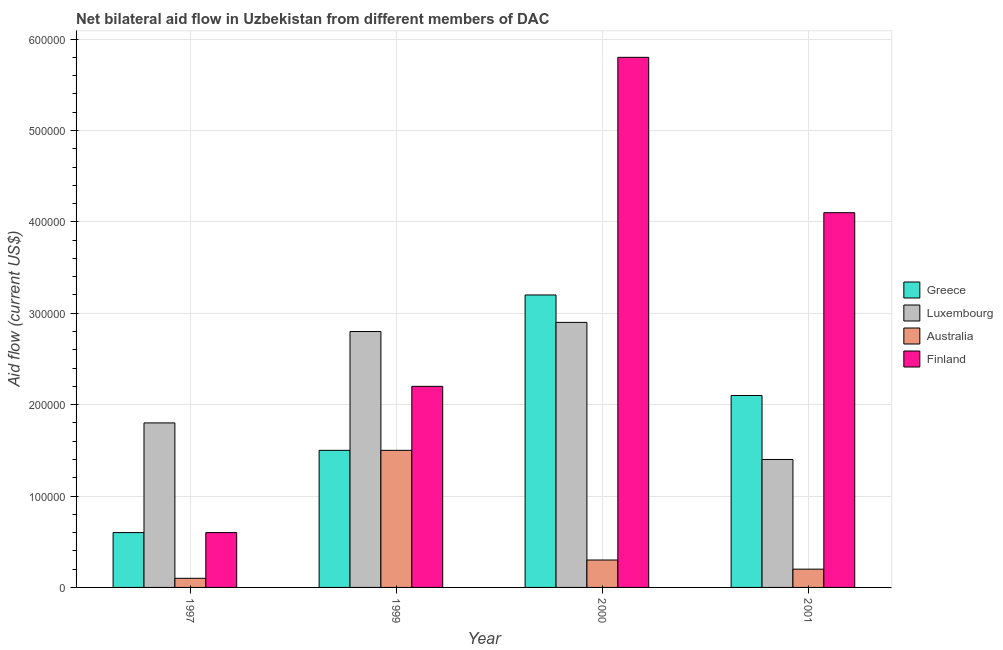How many different coloured bars are there?
Keep it short and to the point. 4. Are the number of bars per tick equal to the number of legend labels?
Offer a very short reply. Yes. How many bars are there on the 3rd tick from the right?
Make the answer very short. 4. In how many cases, is the number of bars for a given year not equal to the number of legend labels?
Your answer should be compact. 0. What is the amount of aid given by finland in 2001?
Give a very brief answer. 4.10e+05. Across all years, what is the maximum amount of aid given by australia?
Keep it short and to the point. 1.50e+05. Across all years, what is the minimum amount of aid given by australia?
Offer a terse response. 10000. In which year was the amount of aid given by finland maximum?
Keep it short and to the point. 2000. In which year was the amount of aid given by luxembourg minimum?
Ensure brevity in your answer.  2001. What is the total amount of aid given by finland in the graph?
Your answer should be very brief. 1.27e+06. What is the difference between the amount of aid given by luxembourg in 1999 and that in 2001?
Offer a very short reply. 1.40e+05. What is the difference between the amount of aid given by finland in 2001 and the amount of aid given by australia in 2000?
Your answer should be compact. -1.70e+05. What is the average amount of aid given by luxembourg per year?
Offer a very short reply. 2.22e+05. In the year 2000, what is the difference between the amount of aid given by australia and amount of aid given by greece?
Make the answer very short. 0. In how many years, is the amount of aid given by greece greater than 240000 US$?
Your answer should be very brief. 1. What is the ratio of the amount of aid given by australia in 1997 to that in 2000?
Give a very brief answer. 0.33. Is the amount of aid given by luxembourg in 1997 less than that in 1999?
Give a very brief answer. Yes. Is the difference between the amount of aid given by luxembourg in 1999 and 2001 greater than the difference between the amount of aid given by finland in 1999 and 2001?
Offer a terse response. No. What is the difference between the highest and the second highest amount of aid given by luxembourg?
Give a very brief answer. 10000. What is the difference between the highest and the lowest amount of aid given by finland?
Offer a very short reply. 5.20e+05. What does the 3rd bar from the left in 2000 represents?
Provide a short and direct response. Australia. Are all the bars in the graph horizontal?
Make the answer very short. No. What is the difference between two consecutive major ticks on the Y-axis?
Give a very brief answer. 1.00e+05. Are the values on the major ticks of Y-axis written in scientific E-notation?
Your response must be concise. No. Does the graph contain any zero values?
Make the answer very short. No. What is the title of the graph?
Make the answer very short. Net bilateral aid flow in Uzbekistan from different members of DAC. Does "Gender equality" appear as one of the legend labels in the graph?
Provide a succinct answer. No. What is the Aid flow (current US$) of Greece in 1997?
Offer a terse response. 6.00e+04. What is the Aid flow (current US$) of Australia in 1997?
Give a very brief answer. 10000. What is the Aid flow (current US$) in Finland in 1997?
Make the answer very short. 6.00e+04. What is the Aid flow (current US$) of Greece in 1999?
Your answer should be compact. 1.50e+05. What is the Aid flow (current US$) of Australia in 1999?
Give a very brief answer. 1.50e+05. What is the Aid flow (current US$) of Greece in 2000?
Your answer should be very brief. 3.20e+05. What is the Aid flow (current US$) of Luxembourg in 2000?
Your answer should be compact. 2.90e+05. What is the Aid flow (current US$) in Finland in 2000?
Keep it short and to the point. 5.80e+05. What is the Aid flow (current US$) of Luxembourg in 2001?
Ensure brevity in your answer.  1.40e+05. What is the Aid flow (current US$) in Finland in 2001?
Offer a very short reply. 4.10e+05. Across all years, what is the maximum Aid flow (current US$) in Luxembourg?
Ensure brevity in your answer.  2.90e+05. Across all years, what is the maximum Aid flow (current US$) in Finland?
Give a very brief answer. 5.80e+05. Across all years, what is the minimum Aid flow (current US$) in Finland?
Provide a succinct answer. 6.00e+04. What is the total Aid flow (current US$) in Greece in the graph?
Ensure brevity in your answer.  7.40e+05. What is the total Aid flow (current US$) of Luxembourg in the graph?
Your answer should be compact. 8.90e+05. What is the total Aid flow (current US$) in Australia in the graph?
Your response must be concise. 2.10e+05. What is the total Aid flow (current US$) in Finland in the graph?
Your response must be concise. 1.27e+06. What is the difference between the Aid flow (current US$) of Finland in 1997 and that in 1999?
Your answer should be very brief. -1.60e+05. What is the difference between the Aid flow (current US$) in Greece in 1997 and that in 2000?
Your answer should be very brief. -2.60e+05. What is the difference between the Aid flow (current US$) in Luxembourg in 1997 and that in 2000?
Your answer should be compact. -1.10e+05. What is the difference between the Aid flow (current US$) in Finland in 1997 and that in 2000?
Keep it short and to the point. -5.20e+05. What is the difference between the Aid flow (current US$) of Greece in 1997 and that in 2001?
Provide a short and direct response. -1.50e+05. What is the difference between the Aid flow (current US$) of Luxembourg in 1997 and that in 2001?
Your answer should be compact. 4.00e+04. What is the difference between the Aid flow (current US$) of Finland in 1997 and that in 2001?
Offer a terse response. -3.50e+05. What is the difference between the Aid flow (current US$) in Greece in 1999 and that in 2000?
Give a very brief answer. -1.70e+05. What is the difference between the Aid flow (current US$) in Finland in 1999 and that in 2000?
Offer a terse response. -3.60e+05. What is the difference between the Aid flow (current US$) of Australia in 1999 and that in 2001?
Make the answer very short. 1.30e+05. What is the difference between the Aid flow (current US$) of Finland in 1999 and that in 2001?
Your response must be concise. -1.90e+05. What is the difference between the Aid flow (current US$) in Greece in 2000 and that in 2001?
Your response must be concise. 1.10e+05. What is the difference between the Aid flow (current US$) in Luxembourg in 2000 and that in 2001?
Your response must be concise. 1.50e+05. What is the difference between the Aid flow (current US$) of Finland in 2000 and that in 2001?
Provide a short and direct response. 1.70e+05. What is the difference between the Aid flow (current US$) of Greece in 1997 and the Aid flow (current US$) of Luxembourg in 1999?
Your answer should be very brief. -2.20e+05. What is the difference between the Aid flow (current US$) of Greece in 1997 and the Aid flow (current US$) of Finland in 1999?
Your answer should be very brief. -1.60e+05. What is the difference between the Aid flow (current US$) in Australia in 1997 and the Aid flow (current US$) in Finland in 1999?
Keep it short and to the point. -2.10e+05. What is the difference between the Aid flow (current US$) in Greece in 1997 and the Aid flow (current US$) in Luxembourg in 2000?
Ensure brevity in your answer.  -2.30e+05. What is the difference between the Aid flow (current US$) of Greece in 1997 and the Aid flow (current US$) of Finland in 2000?
Offer a terse response. -5.20e+05. What is the difference between the Aid flow (current US$) of Luxembourg in 1997 and the Aid flow (current US$) of Finland in 2000?
Make the answer very short. -4.00e+05. What is the difference between the Aid flow (current US$) in Australia in 1997 and the Aid flow (current US$) in Finland in 2000?
Keep it short and to the point. -5.70e+05. What is the difference between the Aid flow (current US$) in Greece in 1997 and the Aid flow (current US$) in Luxembourg in 2001?
Offer a terse response. -8.00e+04. What is the difference between the Aid flow (current US$) of Greece in 1997 and the Aid flow (current US$) of Australia in 2001?
Offer a very short reply. 4.00e+04. What is the difference between the Aid flow (current US$) in Greece in 1997 and the Aid flow (current US$) in Finland in 2001?
Provide a succinct answer. -3.50e+05. What is the difference between the Aid flow (current US$) in Luxembourg in 1997 and the Aid flow (current US$) in Australia in 2001?
Keep it short and to the point. 1.60e+05. What is the difference between the Aid flow (current US$) in Luxembourg in 1997 and the Aid flow (current US$) in Finland in 2001?
Make the answer very short. -2.30e+05. What is the difference between the Aid flow (current US$) of Australia in 1997 and the Aid flow (current US$) of Finland in 2001?
Your answer should be very brief. -4.00e+05. What is the difference between the Aid flow (current US$) of Greece in 1999 and the Aid flow (current US$) of Luxembourg in 2000?
Ensure brevity in your answer.  -1.40e+05. What is the difference between the Aid flow (current US$) of Greece in 1999 and the Aid flow (current US$) of Finland in 2000?
Provide a short and direct response. -4.30e+05. What is the difference between the Aid flow (current US$) in Luxembourg in 1999 and the Aid flow (current US$) in Finland in 2000?
Your response must be concise. -3.00e+05. What is the difference between the Aid flow (current US$) of Australia in 1999 and the Aid flow (current US$) of Finland in 2000?
Provide a short and direct response. -4.30e+05. What is the difference between the Aid flow (current US$) of Greece in 1999 and the Aid flow (current US$) of Luxembourg in 2001?
Ensure brevity in your answer.  10000. What is the difference between the Aid flow (current US$) of Greece in 1999 and the Aid flow (current US$) of Australia in 2001?
Your answer should be very brief. 1.30e+05. What is the difference between the Aid flow (current US$) in Luxembourg in 1999 and the Aid flow (current US$) in Australia in 2001?
Offer a terse response. 2.60e+05. What is the difference between the Aid flow (current US$) of Australia in 1999 and the Aid flow (current US$) of Finland in 2001?
Ensure brevity in your answer.  -2.60e+05. What is the difference between the Aid flow (current US$) of Greece in 2000 and the Aid flow (current US$) of Luxembourg in 2001?
Give a very brief answer. 1.80e+05. What is the difference between the Aid flow (current US$) in Greece in 2000 and the Aid flow (current US$) in Australia in 2001?
Give a very brief answer. 3.00e+05. What is the difference between the Aid flow (current US$) of Luxembourg in 2000 and the Aid flow (current US$) of Australia in 2001?
Your response must be concise. 2.70e+05. What is the difference between the Aid flow (current US$) in Luxembourg in 2000 and the Aid flow (current US$) in Finland in 2001?
Offer a terse response. -1.20e+05. What is the difference between the Aid flow (current US$) of Australia in 2000 and the Aid flow (current US$) of Finland in 2001?
Provide a short and direct response. -3.80e+05. What is the average Aid flow (current US$) in Greece per year?
Offer a very short reply. 1.85e+05. What is the average Aid flow (current US$) of Luxembourg per year?
Your answer should be very brief. 2.22e+05. What is the average Aid flow (current US$) in Australia per year?
Make the answer very short. 5.25e+04. What is the average Aid flow (current US$) of Finland per year?
Your response must be concise. 3.18e+05. In the year 1997, what is the difference between the Aid flow (current US$) of Greece and Aid flow (current US$) of Luxembourg?
Offer a terse response. -1.20e+05. In the year 1997, what is the difference between the Aid flow (current US$) in Australia and Aid flow (current US$) in Finland?
Provide a short and direct response. -5.00e+04. In the year 1999, what is the difference between the Aid flow (current US$) of Greece and Aid flow (current US$) of Luxembourg?
Your response must be concise. -1.30e+05. In the year 1999, what is the difference between the Aid flow (current US$) of Luxembourg and Aid flow (current US$) of Finland?
Offer a very short reply. 6.00e+04. In the year 1999, what is the difference between the Aid flow (current US$) of Australia and Aid flow (current US$) of Finland?
Provide a short and direct response. -7.00e+04. In the year 2000, what is the difference between the Aid flow (current US$) of Greece and Aid flow (current US$) of Australia?
Provide a short and direct response. 2.90e+05. In the year 2000, what is the difference between the Aid flow (current US$) in Greece and Aid flow (current US$) in Finland?
Provide a short and direct response. -2.60e+05. In the year 2000, what is the difference between the Aid flow (current US$) of Luxembourg and Aid flow (current US$) of Australia?
Give a very brief answer. 2.60e+05. In the year 2000, what is the difference between the Aid flow (current US$) in Luxembourg and Aid flow (current US$) in Finland?
Give a very brief answer. -2.90e+05. In the year 2000, what is the difference between the Aid flow (current US$) of Australia and Aid flow (current US$) of Finland?
Your answer should be compact. -5.50e+05. In the year 2001, what is the difference between the Aid flow (current US$) of Greece and Aid flow (current US$) of Australia?
Make the answer very short. 1.90e+05. In the year 2001, what is the difference between the Aid flow (current US$) in Greece and Aid flow (current US$) in Finland?
Provide a succinct answer. -2.00e+05. In the year 2001, what is the difference between the Aid flow (current US$) in Luxembourg and Aid flow (current US$) in Australia?
Your answer should be compact. 1.20e+05. In the year 2001, what is the difference between the Aid flow (current US$) in Luxembourg and Aid flow (current US$) in Finland?
Give a very brief answer. -2.70e+05. In the year 2001, what is the difference between the Aid flow (current US$) of Australia and Aid flow (current US$) of Finland?
Make the answer very short. -3.90e+05. What is the ratio of the Aid flow (current US$) of Luxembourg in 1997 to that in 1999?
Your answer should be very brief. 0.64. What is the ratio of the Aid flow (current US$) of Australia in 1997 to that in 1999?
Your answer should be compact. 0.07. What is the ratio of the Aid flow (current US$) of Finland in 1997 to that in 1999?
Keep it short and to the point. 0.27. What is the ratio of the Aid flow (current US$) of Greece in 1997 to that in 2000?
Your answer should be very brief. 0.19. What is the ratio of the Aid flow (current US$) in Luxembourg in 1997 to that in 2000?
Ensure brevity in your answer.  0.62. What is the ratio of the Aid flow (current US$) in Australia in 1997 to that in 2000?
Give a very brief answer. 0.33. What is the ratio of the Aid flow (current US$) of Finland in 1997 to that in 2000?
Your response must be concise. 0.1. What is the ratio of the Aid flow (current US$) of Greece in 1997 to that in 2001?
Ensure brevity in your answer.  0.29. What is the ratio of the Aid flow (current US$) in Luxembourg in 1997 to that in 2001?
Your answer should be compact. 1.29. What is the ratio of the Aid flow (current US$) in Australia in 1997 to that in 2001?
Offer a very short reply. 0.5. What is the ratio of the Aid flow (current US$) of Finland in 1997 to that in 2001?
Ensure brevity in your answer.  0.15. What is the ratio of the Aid flow (current US$) in Greece in 1999 to that in 2000?
Give a very brief answer. 0.47. What is the ratio of the Aid flow (current US$) in Luxembourg in 1999 to that in 2000?
Your answer should be compact. 0.97. What is the ratio of the Aid flow (current US$) in Finland in 1999 to that in 2000?
Your answer should be compact. 0.38. What is the ratio of the Aid flow (current US$) in Greece in 1999 to that in 2001?
Your response must be concise. 0.71. What is the ratio of the Aid flow (current US$) in Finland in 1999 to that in 2001?
Your answer should be very brief. 0.54. What is the ratio of the Aid flow (current US$) in Greece in 2000 to that in 2001?
Your answer should be very brief. 1.52. What is the ratio of the Aid flow (current US$) in Luxembourg in 2000 to that in 2001?
Give a very brief answer. 2.07. What is the ratio of the Aid flow (current US$) of Finland in 2000 to that in 2001?
Your answer should be very brief. 1.41. What is the difference between the highest and the second highest Aid flow (current US$) in Luxembourg?
Your answer should be very brief. 10000. What is the difference between the highest and the lowest Aid flow (current US$) of Greece?
Provide a succinct answer. 2.60e+05. What is the difference between the highest and the lowest Aid flow (current US$) of Luxembourg?
Provide a short and direct response. 1.50e+05. What is the difference between the highest and the lowest Aid flow (current US$) of Australia?
Your answer should be compact. 1.40e+05. What is the difference between the highest and the lowest Aid flow (current US$) in Finland?
Ensure brevity in your answer.  5.20e+05. 